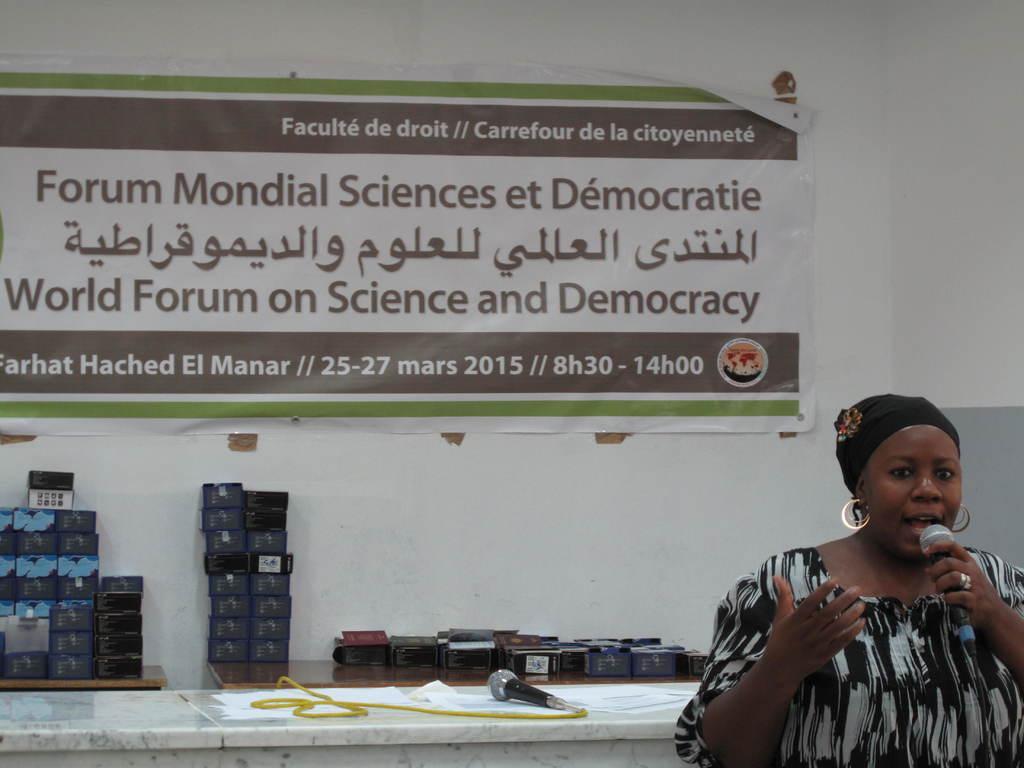Could you give a brief overview of what you see in this image? In this picture we can see a woman, she is holding a mic and in the background we can see tables, mic, boxes, wall, banner and some objects. 